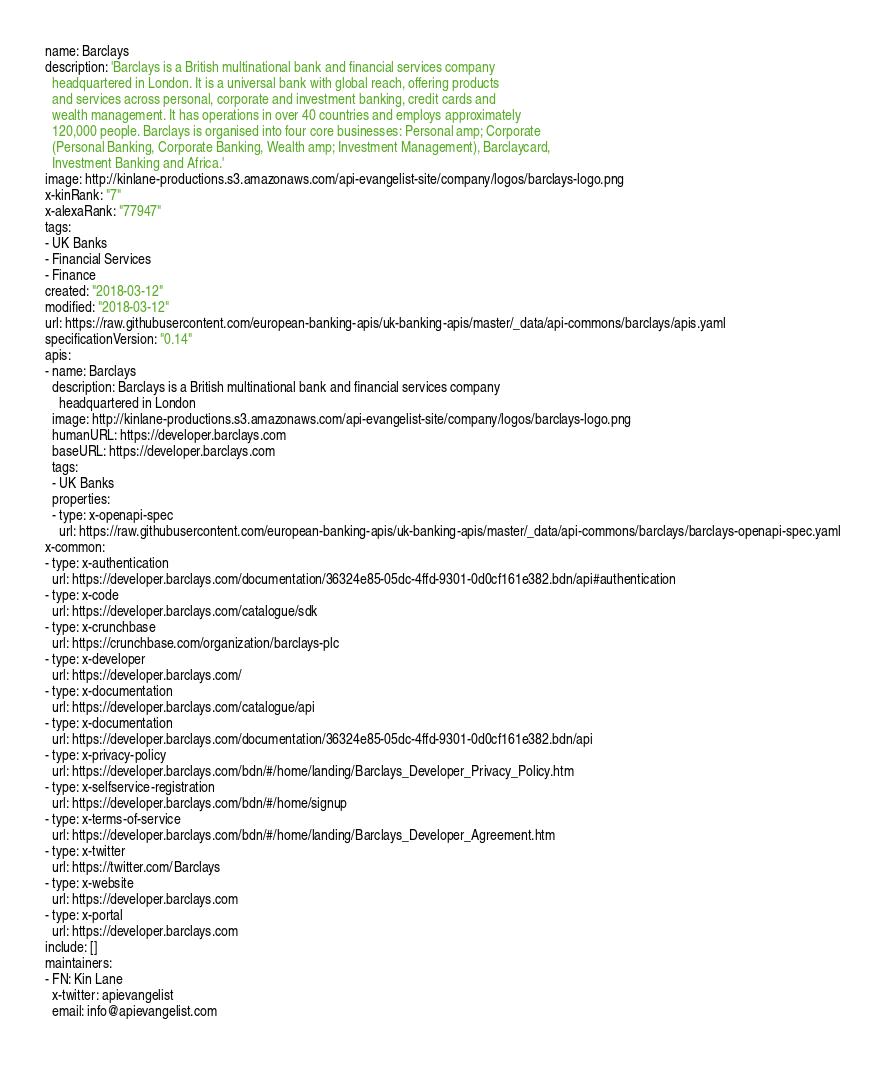<code> <loc_0><loc_0><loc_500><loc_500><_YAML_>name: Barclays
description: 'Barclays is a British multinational bank and financial services company
  headquartered in London. It is a universal bank with global reach, offering products
  and services across personal, corporate and investment banking, credit cards and
  wealth management. It has operations in over 40 countries and employs approximately
  120,000 people. Barclays is organised into four core businesses: Personal amp; Corporate
  (Personal Banking, Corporate Banking, Wealth amp; Investment Management), Barclaycard,
  Investment Banking and Africa.'
image: http://kinlane-productions.s3.amazonaws.com/api-evangelist-site/company/logos/barclays-logo.png
x-kinRank: "7"
x-alexaRank: "77947"
tags:
- UK Banks
- Financial Services
- Finance
created: "2018-03-12"
modified: "2018-03-12"
url: https://raw.githubusercontent.com/european-banking-apis/uk-banking-apis/master/_data/api-commons/barclays/apis.yaml
specificationVersion: "0.14"
apis:
- name: Barclays
  description: Barclays is a British multinational bank and financial services company
    headquartered in London
  image: http://kinlane-productions.s3.amazonaws.com/api-evangelist-site/company/logos/barclays-logo.png
  humanURL: https://developer.barclays.com
  baseURL: https://developer.barclays.com
  tags:
  - UK Banks
  properties:
  - type: x-openapi-spec
    url: https://raw.githubusercontent.com/european-banking-apis/uk-banking-apis/master/_data/api-commons/barclays/barclays-openapi-spec.yaml
x-common:
- type: x-authentication
  url: https://developer.barclays.com/documentation/36324e85-05dc-4ffd-9301-0d0cf161e382.bdn/api#authentication
- type: x-code
  url: https://developer.barclays.com/catalogue/sdk
- type: x-crunchbase
  url: https://crunchbase.com/organization/barclays-plc
- type: x-developer
  url: https://developer.barclays.com/
- type: x-documentation
  url: https://developer.barclays.com/catalogue/api
- type: x-documentation
  url: https://developer.barclays.com/documentation/36324e85-05dc-4ffd-9301-0d0cf161e382.bdn/api
- type: x-privacy-policy
  url: https://developer.barclays.com/bdn/#/home/landing/Barclays_Developer_Privacy_Policy.htm
- type: x-selfservice-registration
  url: https://developer.barclays.com/bdn/#/home/signup
- type: x-terms-of-service
  url: https://developer.barclays.com/bdn/#/home/landing/Barclays_Developer_Agreement.htm
- type: x-twitter
  url: https://twitter.com/Barclays
- type: x-website
  url: https://developer.barclays.com
- type: x-portal
  url: https://developer.barclays.com
include: []
maintainers:
- FN: Kin Lane
  x-twitter: apievangelist
  email: info@apievangelist.com</code> 